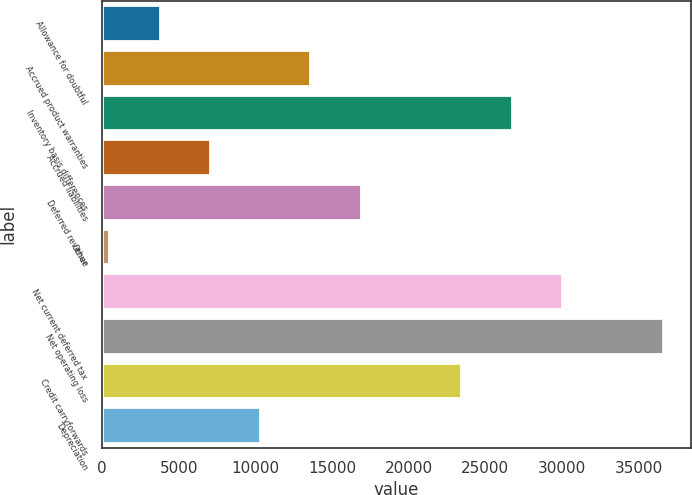Convert chart to OTSL. <chart><loc_0><loc_0><loc_500><loc_500><bar_chart><fcel>Allowance for doubtful<fcel>Accrued product warranties<fcel>Inventory basis differences<fcel>Accrued liabilities<fcel>Deferred revenue<fcel>Other<fcel>Net current deferred tax<fcel>Net operating loss<fcel>Credit carryforwards<fcel>Depreciation<nl><fcel>3740.6<fcel>13588.4<fcel>26718.8<fcel>7023.2<fcel>16871<fcel>458<fcel>30001.4<fcel>36566.6<fcel>23436.2<fcel>10305.8<nl></chart> 